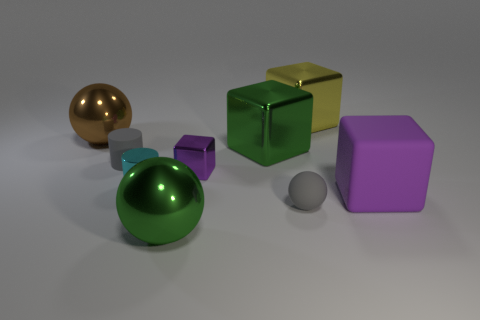Subtract 1 blocks. How many blocks are left? 3 Add 1 blue metallic cylinders. How many objects exist? 10 Subtract all spheres. How many objects are left? 6 Add 9 small green rubber cubes. How many small green rubber cubes exist? 9 Subtract 0 red balls. How many objects are left? 9 Subtract all green shiny blocks. Subtract all large yellow objects. How many objects are left? 7 Add 4 green shiny balls. How many green shiny balls are left? 5 